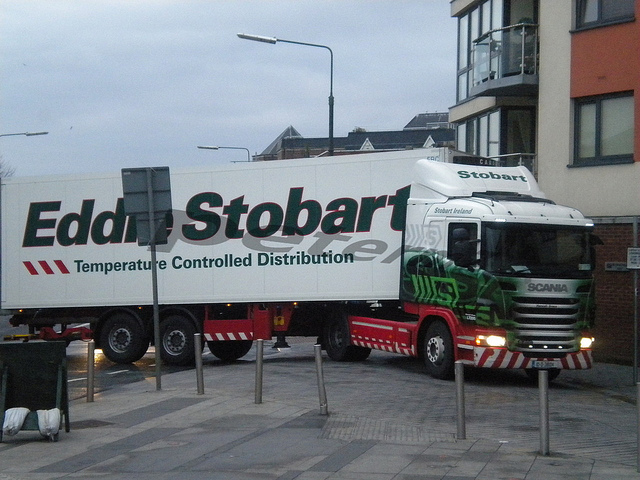Can you tell me what kind of vehicle is in the picture? The image shows a large commercial vehicle, specifically a semi-trailer truck used for temperature-controlled distribution. The truck's design indicates it is equipped for transporting goods that need to be kept at a certain temperature, commonly food or medical supplies. 